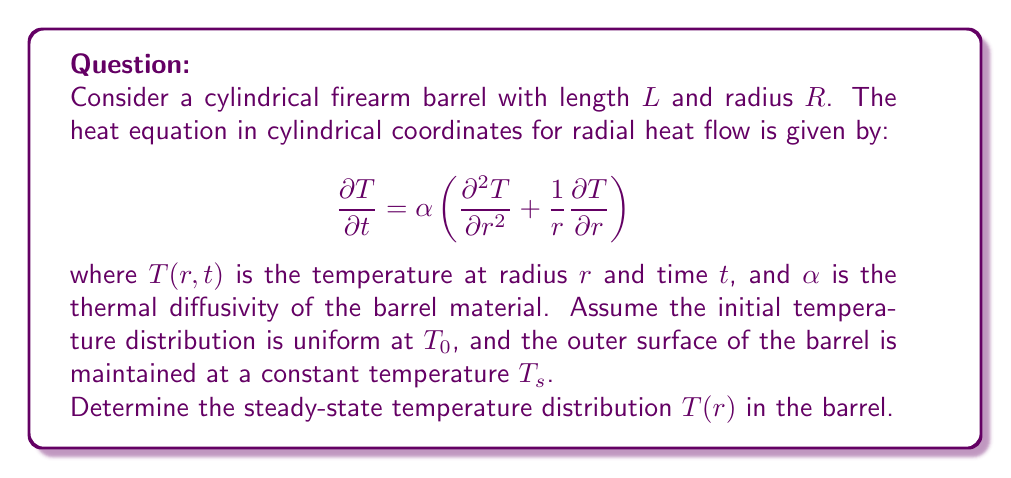Can you solve this math problem? To solve this problem, we need to follow these steps:

1) For the steady-state solution, the temperature doesn't change with time, so $\frac{\partial T}{\partial t} = 0$. This reduces our equation to:

   $$0 = \frac{d^2 T}{dr^2} + \frac{1}{r}\frac{dT}{dr}$$

2) This is a second-order ordinary differential equation. We can solve it by substituting $u = \frac{dT}{dr}$:

   $$\frac{du}{dr} + \frac{1}{r}u = 0$$

3) This is a first-order linear differential equation. The solution is:

   $$u = \frac{C_1}{r}$$

4) Integrating both sides:

   $$T = C_1 \ln(r) + C_2$$

5) Now we apply the boundary conditions:
   - At $r = R$, $T = T_s$
   - At $r = 0$, $T$ must be finite

6) The second condition implies $C_1 = 0$, because $\ln(0)$ is undefined.

7) From the first condition:

   $$T_s = C_2$$

Therefore, the steady-state temperature distribution is constant throughout the barrel and equal to the surface temperature:

$$T(r) = T_s$$

This makes physical sense because in steady-state, with no internal heat generation and a constant surface temperature, the entire barrel will eventually reach the same temperature as the surface.
Answer: The steady-state temperature distribution in the firearm barrel is:

$$T(r) = T_s$$

where $T_s$ is the constant temperature maintained at the outer surface of the barrel. 